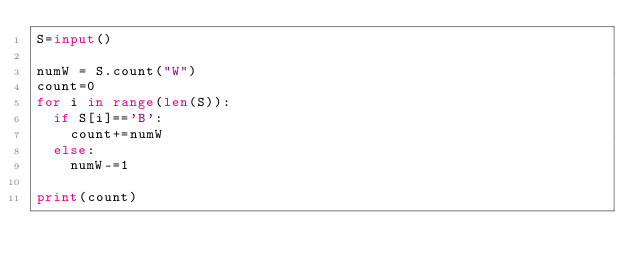Convert code to text. <code><loc_0><loc_0><loc_500><loc_500><_Python_>S=input()

numW = S.count("W")
count=0
for i in range(len(S)):
	if S[i]=='B':
		count+=numW
	else:
		numW-=1

print(count)</code> 